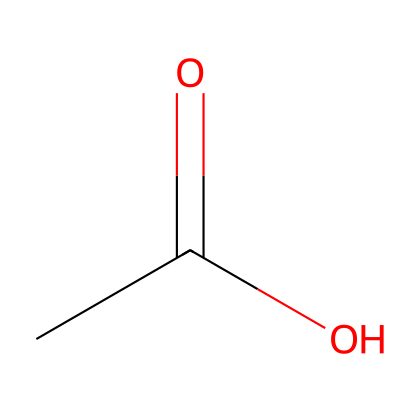What is the common name for this chemical? The SMILES representation CC(=O)O corresponds to acetic acid, which is commonly known as vinegar.
Answer: acetic acid How many hydrogen atoms are in this molecule? By analyzing the SMILES, there are three hydrogen atoms attached to the carbon and one hydrogen associated with the carboxylic acid group (the -COOH), totaling four.
Answer: four What functional group is present in this chemical? The presence of the -COOH group indicates that this chemical contains a carboxylic acid functional group, which is characteristic of all acids.
Answer: carboxylic acid Does this chemical release hydrogen ions in solution? As a weak acid, acetic acid does dissociate in water to release hydrogen ions (H+) making the solution acidic.
Answer: yes What type of reaction would acetic acid undergo with sodium bicarbonate? Acetic acid reacts with sodium bicarbonate in an acid-base reaction, producing carbon dioxide, water, and sodium acetate, indicating it is a typical acid-base reaction.
Answer: acid-base reaction How does this chemical affect metallic surfaces? Acetic acid, although a weak acid, can help remove tarnish and corrosion from metals due to its ability to react with oxides and carbonates found on metal surfaces.
Answer: removes tarnish 